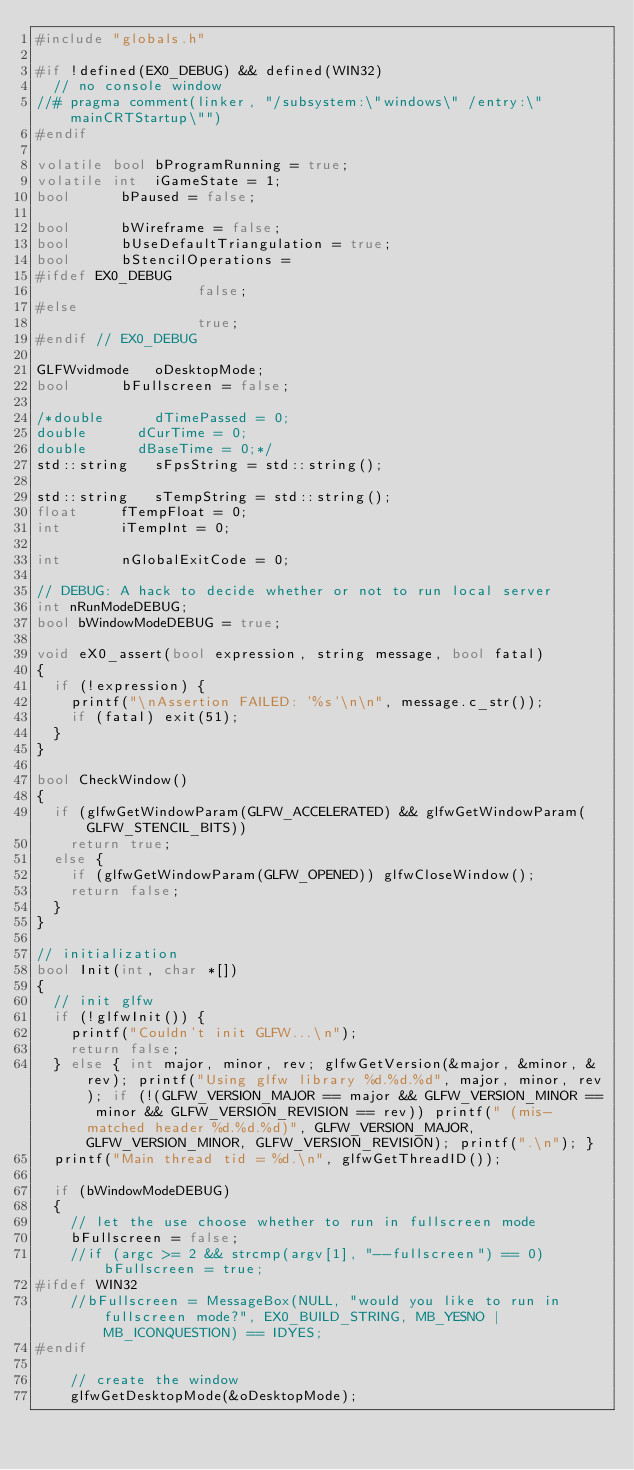<code> <loc_0><loc_0><loc_500><loc_500><_C++_>#include "globals.h"

#if !defined(EX0_DEBUG) && defined(WIN32)
	// no console window
//#	pragma comment(linker, "/subsystem:\"windows\" /entry:\"mainCRTStartup\"")
#endif

volatile bool	bProgramRunning = true;
volatile int	iGameState = 1;
bool			bPaused = false;

bool			bWireframe = false;
bool			bUseDefaultTriangulation = true;
bool			bStencilOperations =
#ifdef EX0_DEBUG
									 false;
#else
									 true;
#endif // EX0_DEBUG

GLFWvidmode		oDesktopMode;
bool			bFullscreen = false;

/*double			dTimePassed = 0;
double			dCurTime = 0;
double			dBaseTime = 0;*/
std::string		sFpsString = std::string();

std::string		sTempString = std::string();
float			fTempFloat = 0;
int				iTempInt = 0;

int				nGlobalExitCode = 0;

// DEBUG: A hack to decide whether or not to run local server
int nRunModeDEBUG;
bool bWindowModeDEBUG = true;

void eX0_assert(bool expression, string message, bool fatal)
{
	if (!expression) {
		printf("\nAssertion FAILED: '%s'\n\n", message.c_str());
		if (fatal) exit(51);
	}
}

bool CheckWindow()
{
	if (glfwGetWindowParam(GLFW_ACCELERATED) && glfwGetWindowParam(GLFW_STENCIL_BITS))
		return true;
	else {
		if (glfwGetWindowParam(GLFW_OPENED)) glfwCloseWindow();
		return false;
	}
}

// initialization
bool Init(int, char *[])
{
	// init glfw
	if (!glfwInit()) {
		printf("Couldn't init GLFW...\n");
		return false;
	} else { int major, minor, rev; glfwGetVersion(&major, &minor, &rev); printf("Using glfw library %d.%d.%d", major, minor, rev); if (!(GLFW_VERSION_MAJOR == major && GLFW_VERSION_MINOR == minor && GLFW_VERSION_REVISION == rev)) printf(" (mis-matched header %d.%d.%d)", GLFW_VERSION_MAJOR, GLFW_VERSION_MINOR, GLFW_VERSION_REVISION); printf(".\n"); }
	printf("Main thread tid = %d.\n", glfwGetThreadID());

	if (bWindowModeDEBUG)
	{
		// let the use choose whether to run in fullscreen mode
		bFullscreen = false;
		//if (argc >= 2 && strcmp(argv[1], "--fullscreen") == 0) bFullscreen = true;
#ifdef WIN32
		//bFullscreen = MessageBox(NULL, "would you like to run in fullscreen mode?", EX0_BUILD_STRING, MB_YESNO | MB_ICONQUESTION) == IDYES;
#endif

		// create the window
		glfwGetDesktopMode(&oDesktopMode);</code> 